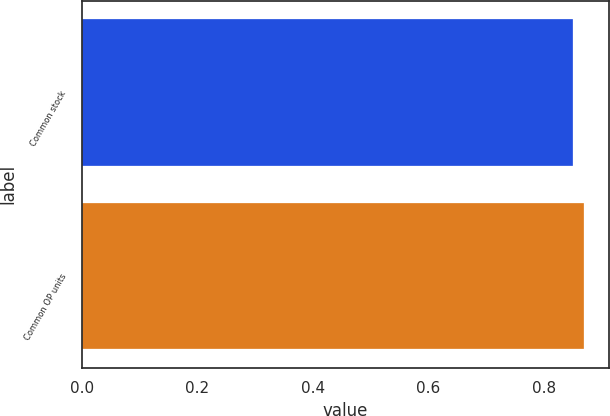<chart> <loc_0><loc_0><loc_500><loc_500><bar_chart><fcel>Common stock<fcel>Common OP units<nl><fcel>0.85<fcel>0.87<nl></chart> 